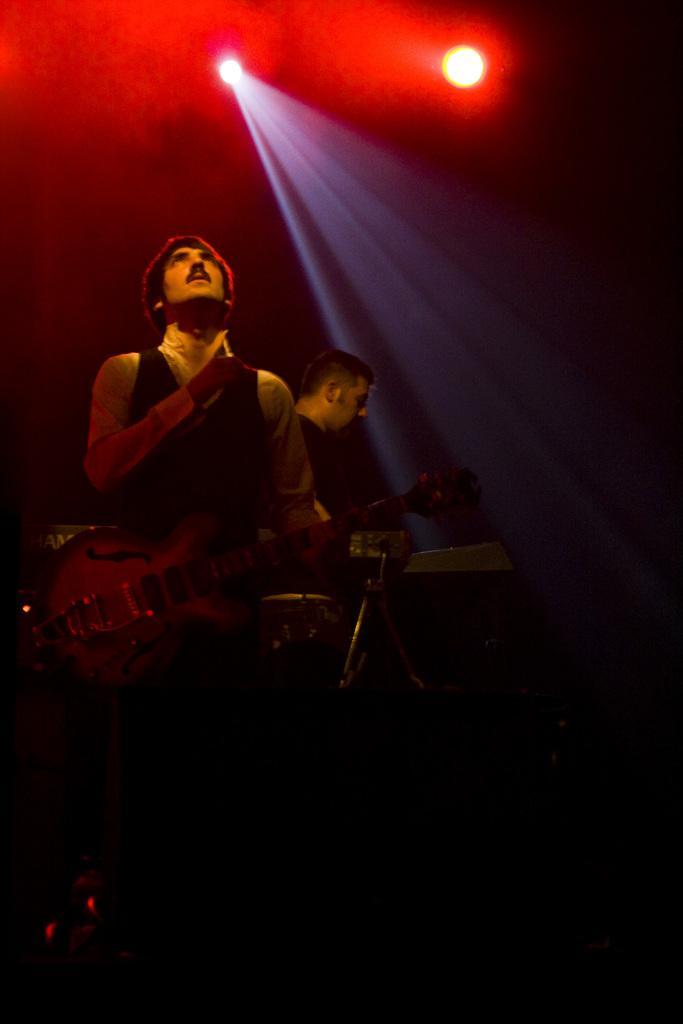What is the person in the foreground of the image doing? The person in the foreground of the image is standing and holding a guitar. Can you describe the person in the background of the image? There is another person standing in the background of the image. What can be seen in the image besides the people? There are lights visible in the image. What type of texture can be seen on the guitar in the image? There is no information about the texture of the guitar in the image. 